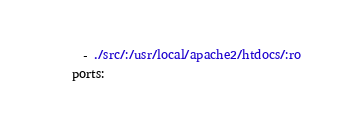<code> <loc_0><loc_0><loc_500><loc_500><_YAML_>      - ./src/:/usr/local/apache2/htdocs/:ro
    ports:</code> 